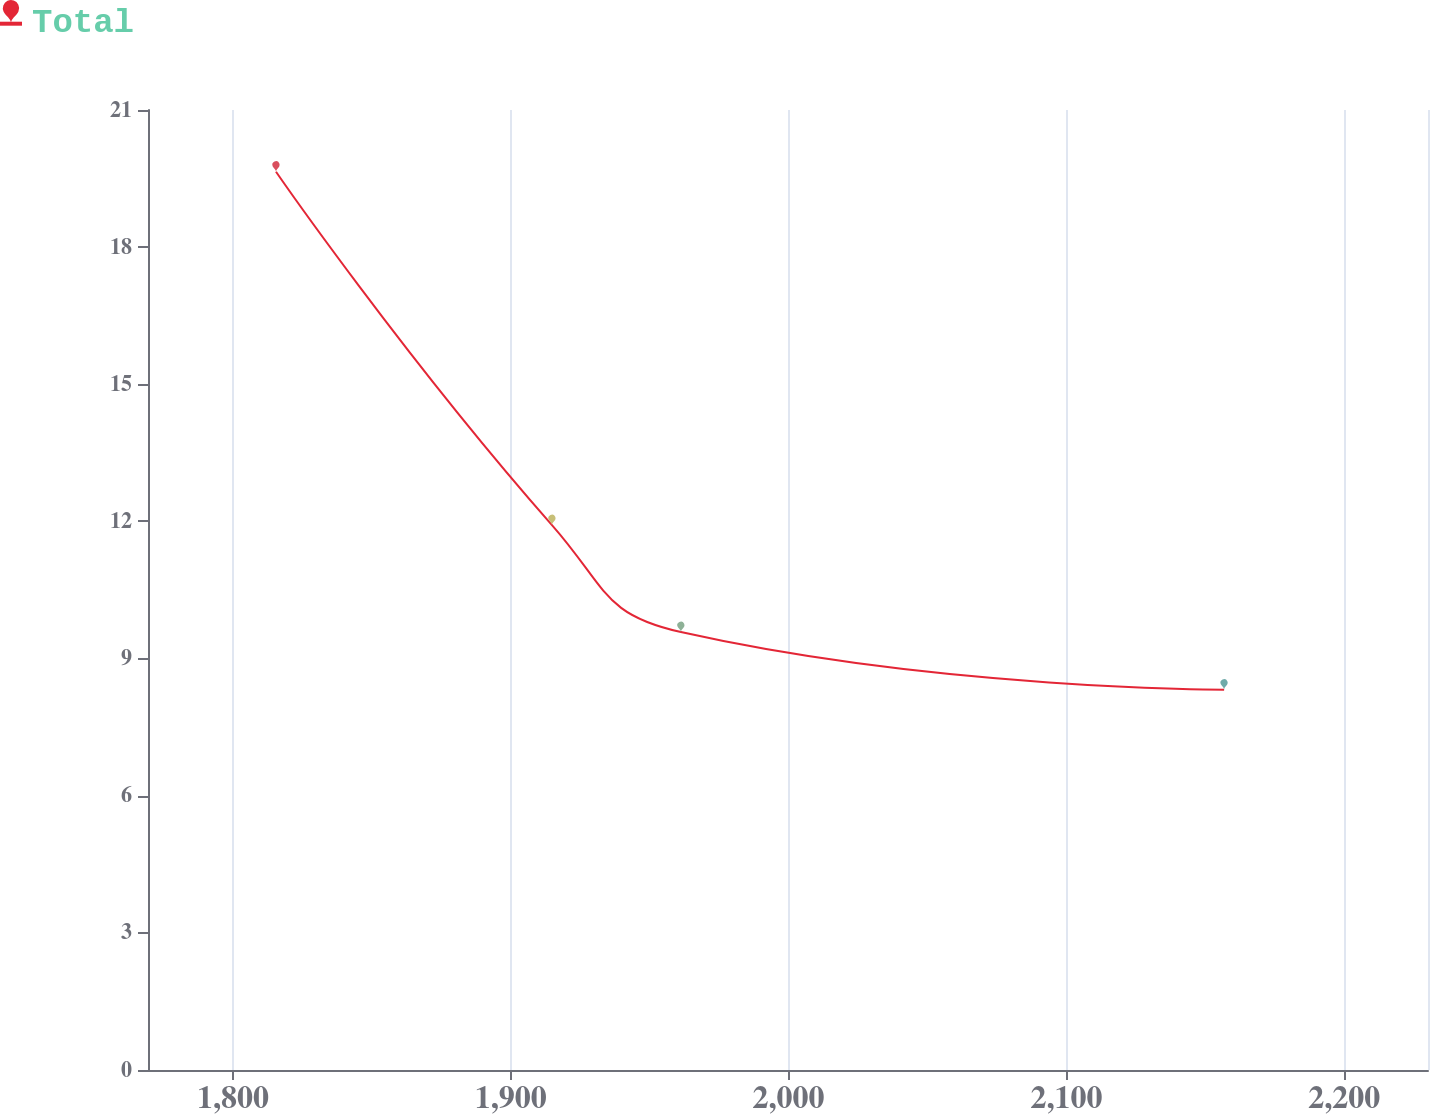<chart> <loc_0><loc_0><loc_500><loc_500><line_chart><ecel><fcel>Total<nl><fcel>1815.5<fcel>19.65<nl><fcel>1914.83<fcel>11.92<nl><fcel>1961.23<fcel>9.58<nl><fcel>2156.74<fcel>8.32<nl><fcel>2276.2<fcel>7.06<nl></chart> 